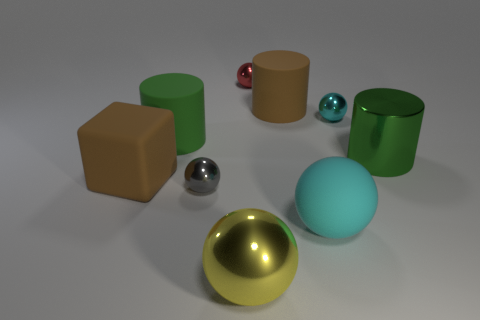Subtract all big yellow metallic spheres. How many spheres are left? 4 Subtract all gray balls. How many balls are left? 4 Subtract 1 spheres. How many spheres are left? 4 Subtract all red spheres. Subtract all purple cylinders. How many spheres are left? 4 Add 1 big yellow shiny objects. How many objects exist? 10 Subtract all balls. How many objects are left? 4 Subtract all big brown rubber cylinders. Subtract all large purple rubber cylinders. How many objects are left? 8 Add 9 big matte balls. How many big matte balls are left? 10 Add 6 metal spheres. How many metal spheres exist? 10 Subtract 0 green cubes. How many objects are left? 9 